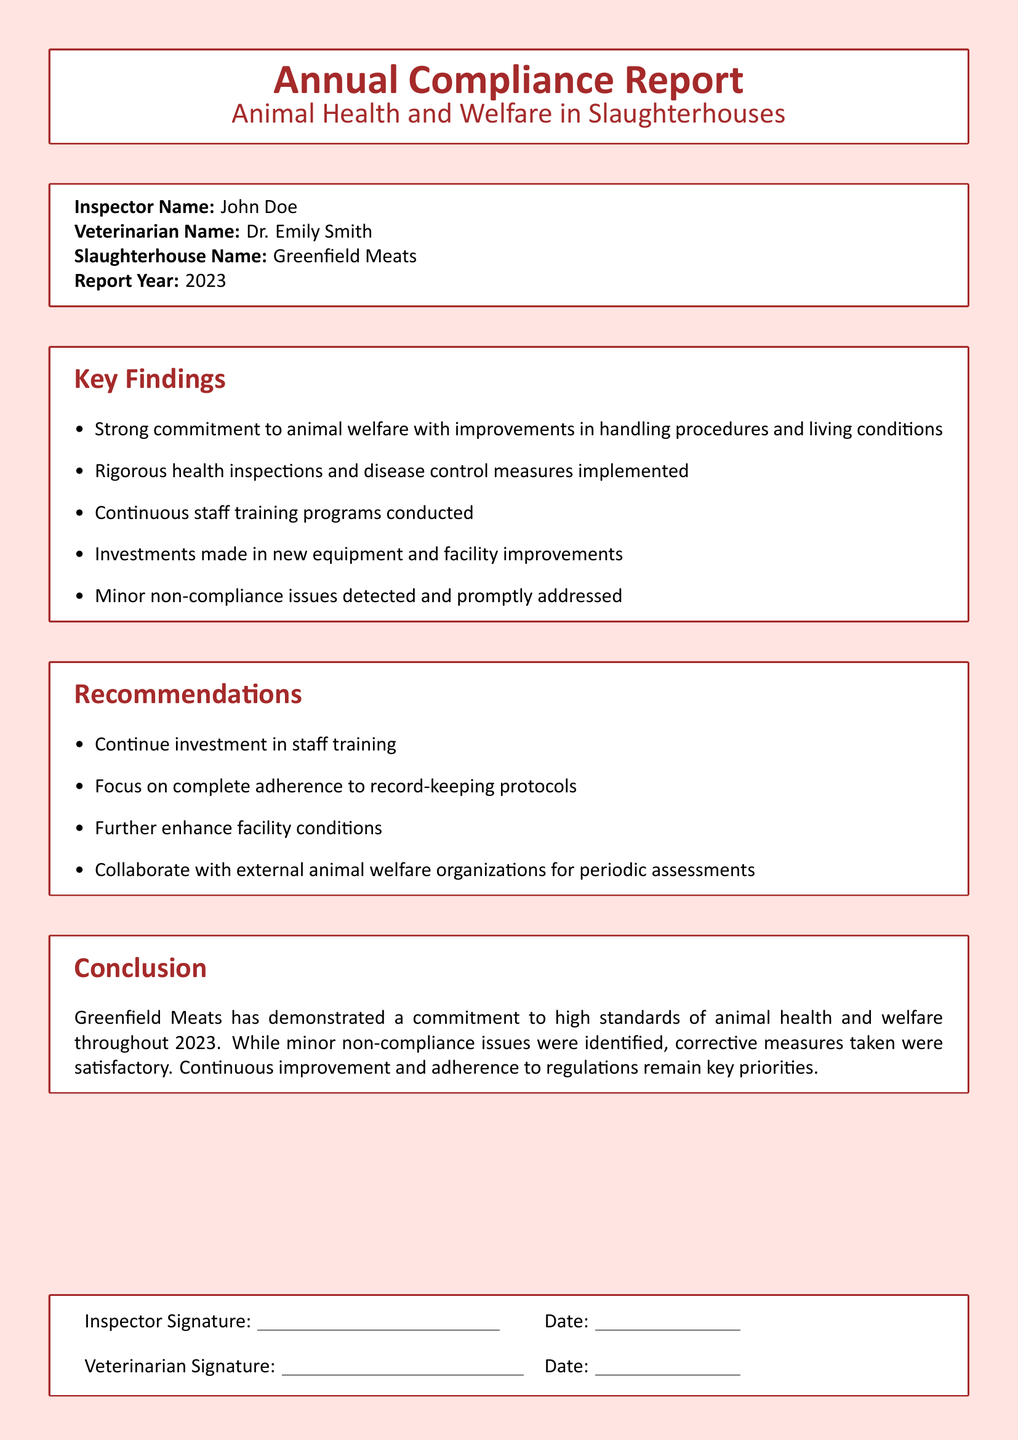What is the Inspector's name? The Inspector's name is mentioned at the beginning of the document in the inspector details section.
Answer: John Doe What year is the report for? The report year is clearly stated in the inspector details section of the document.
Answer: 2023 What is the name of the veterinarian? The veterinarian's name is provided in the inspector details section of the document.
Answer: Dr. Emily Smith What are the key findings about staff training? The key findings mention the ongoing implementation of staff training programs as a notable point.
Answer: Continuous staff training programs conducted What should be the focus for record-keeping protocols? The recommendations section highlights an area of focus regarding record-keeping protocols throughout the related information.
Answer: Complete adherence to record-keeping protocols What institution conducted the health inspections? The entity responsible for rigorous health inspections is described in the key findings of the document.
Answer: Greenfield Meats What were the minor issues detected? The documentation notes that there were non-compliance issues detected but does not explicitly list them; it is implied they were minor.
Answer: Minor non-compliance issues What type of collaboration is recommended? The recommendations specify collaborating with organizations for assessments, indicating the nature of cooperation expected.
Answer: External animal welfare organizations What did the conclusion state about compliance issues? The conclusion provides an overview of the compliance issues noted in the report, specifically their nature and how they were handled.
Answer: Minor non-compliance issues were identified, corrective measures taken were satisfactory 